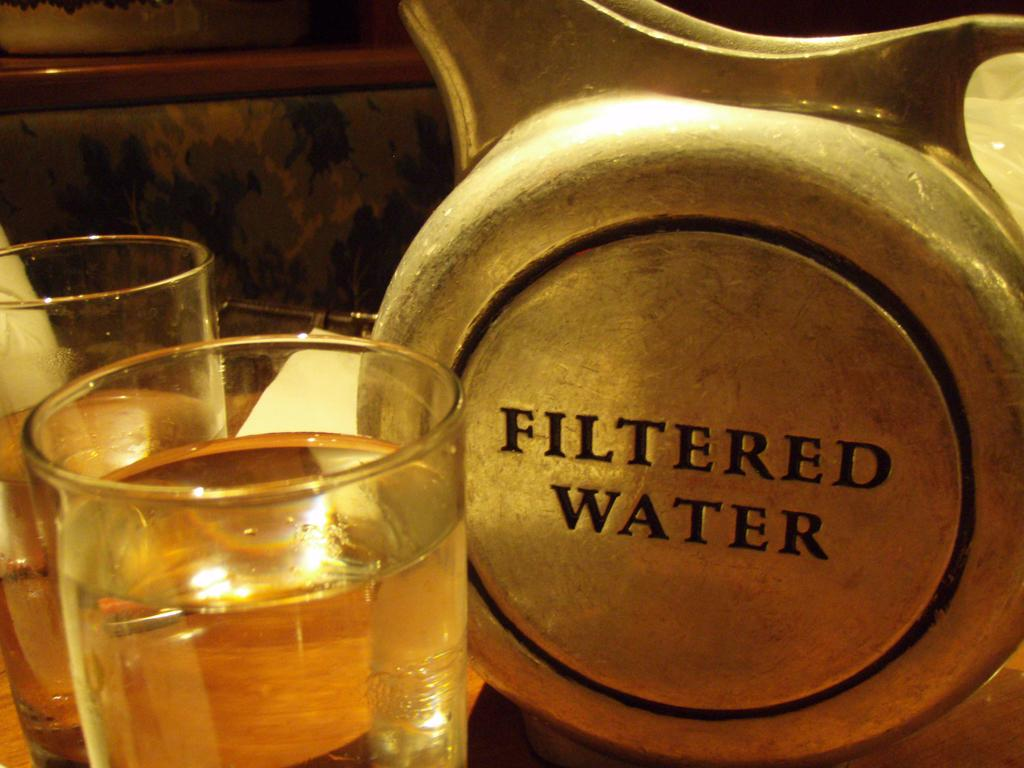<image>
Write a terse but informative summary of the picture. Two glases of filtered water next to a large metal pitcher. 